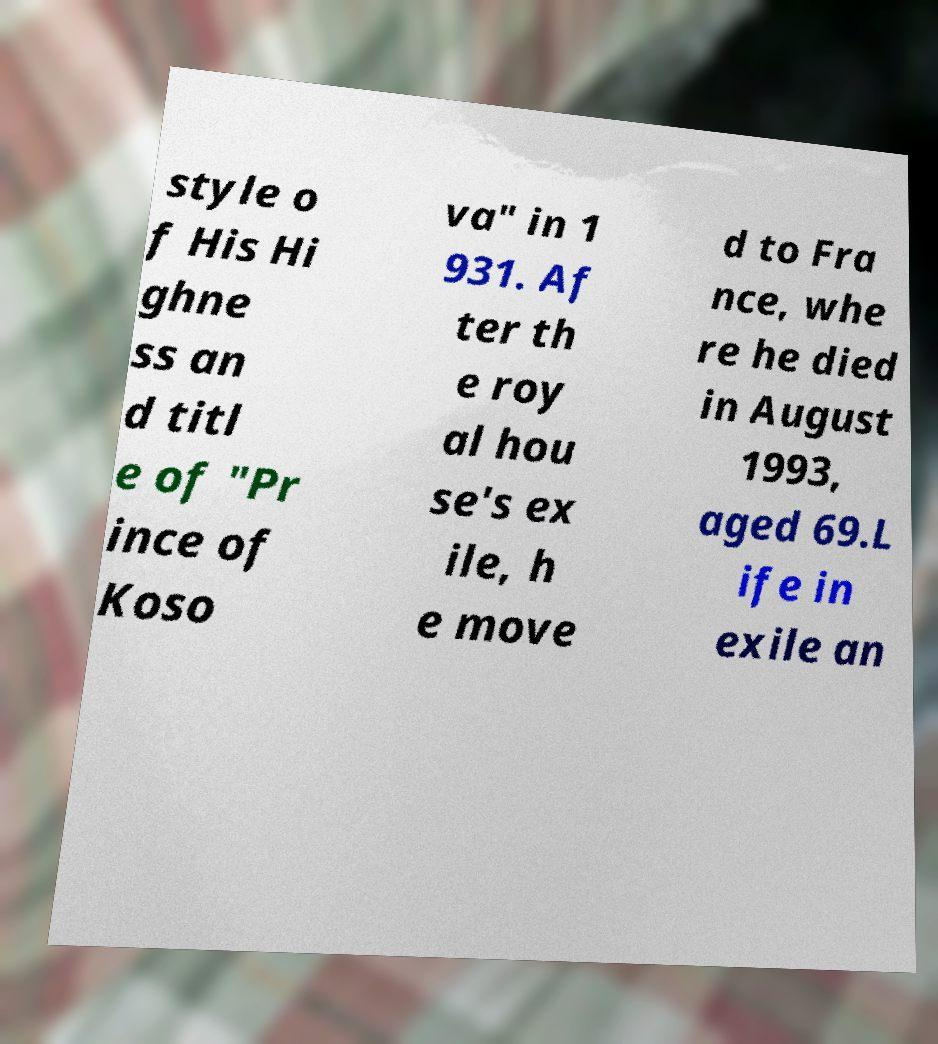I need the written content from this picture converted into text. Can you do that? style o f His Hi ghne ss an d titl e of "Pr ince of Koso va" in 1 931. Af ter th e roy al hou se's ex ile, h e move d to Fra nce, whe re he died in August 1993, aged 69.L ife in exile an 